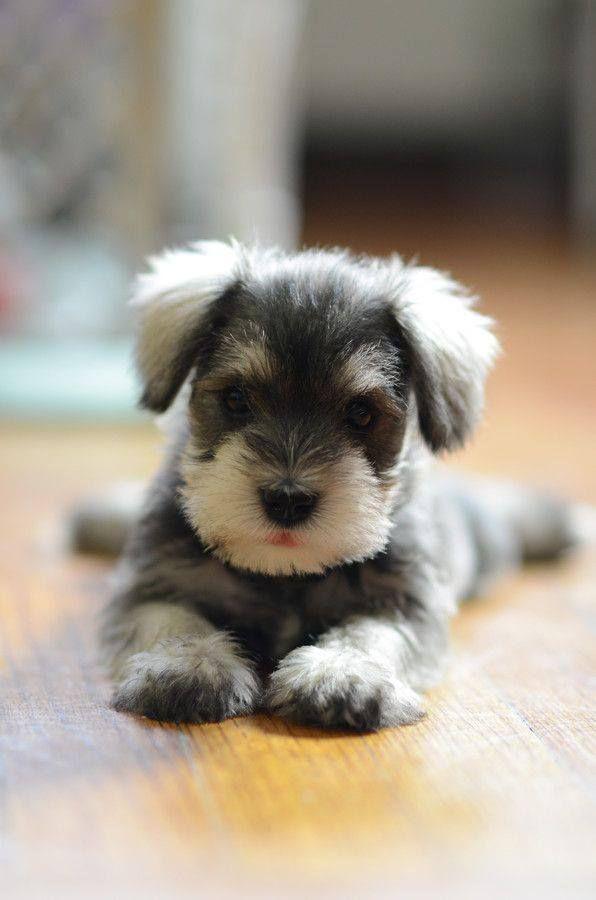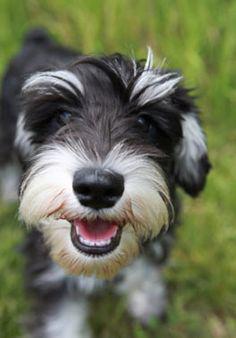The first image is the image on the left, the second image is the image on the right. Evaluate the accuracy of this statement regarding the images: "Right image shows a dog looking upward, with mouth open.". Is it true? Answer yes or no. Yes. The first image is the image on the left, the second image is the image on the right. For the images shown, is this caption "The dog in the right image has its mouth open as it stands in the grass." true? Answer yes or no. Yes. 